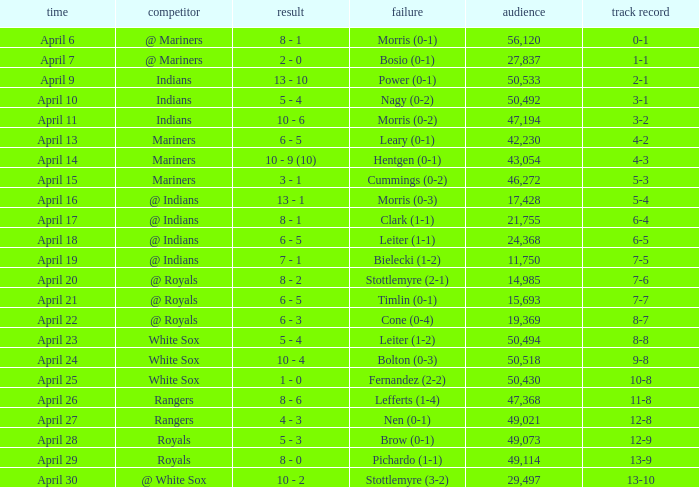What scored is recorded on April 24? 10 - 4. 